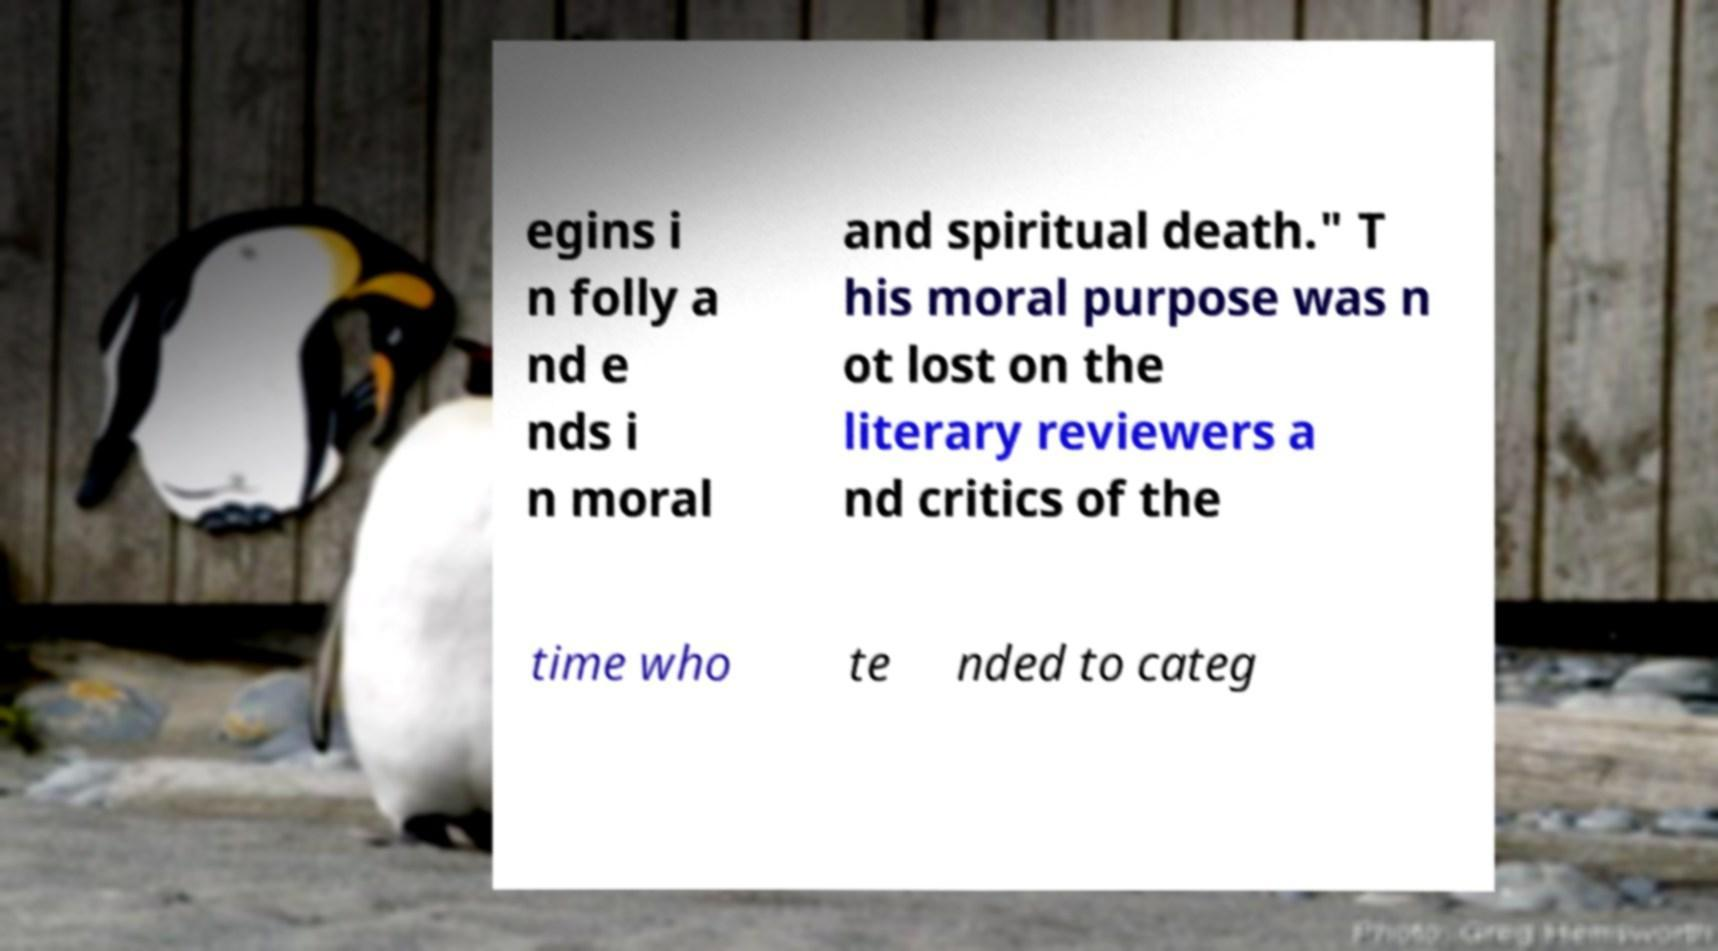Can you read and provide the text displayed in the image?This photo seems to have some interesting text. Can you extract and type it out for me? egins i n folly a nd e nds i n moral and spiritual death." T his moral purpose was n ot lost on the literary reviewers a nd critics of the time who te nded to categ 